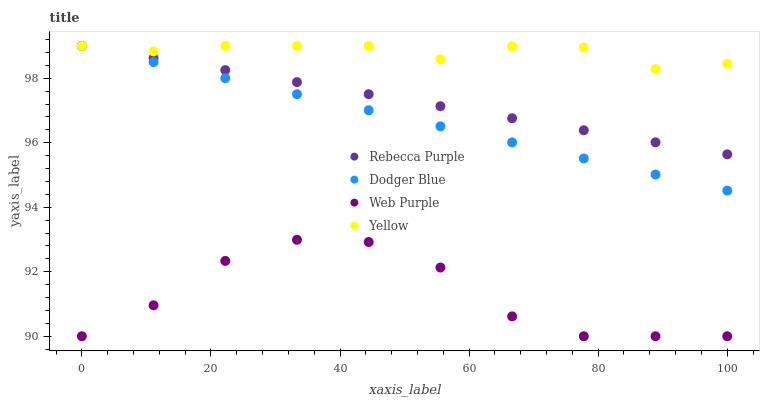Does Web Purple have the minimum area under the curve?
Answer yes or no. Yes. Does Yellow have the maximum area under the curve?
Answer yes or no. Yes. Does Dodger Blue have the minimum area under the curve?
Answer yes or no. No. Does Dodger Blue have the maximum area under the curve?
Answer yes or no. No. Is Rebecca Purple the smoothest?
Answer yes or no. Yes. Is Web Purple the roughest?
Answer yes or no. Yes. Is Dodger Blue the smoothest?
Answer yes or no. No. Is Dodger Blue the roughest?
Answer yes or no. No. Does Web Purple have the lowest value?
Answer yes or no. Yes. Does Dodger Blue have the lowest value?
Answer yes or no. No. Does Yellow have the highest value?
Answer yes or no. Yes. Is Web Purple less than Dodger Blue?
Answer yes or no. Yes. Is Rebecca Purple greater than Web Purple?
Answer yes or no. Yes. Does Rebecca Purple intersect Yellow?
Answer yes or no. Yes. Is Rebecca Purple less than Yellow?
Answer yes or no. No. Is Rebecca Purple greater than Yellow?
Answer yes or no. No. Does Web Purple intersect Dodger Blue?
Answer yes or no. No. 